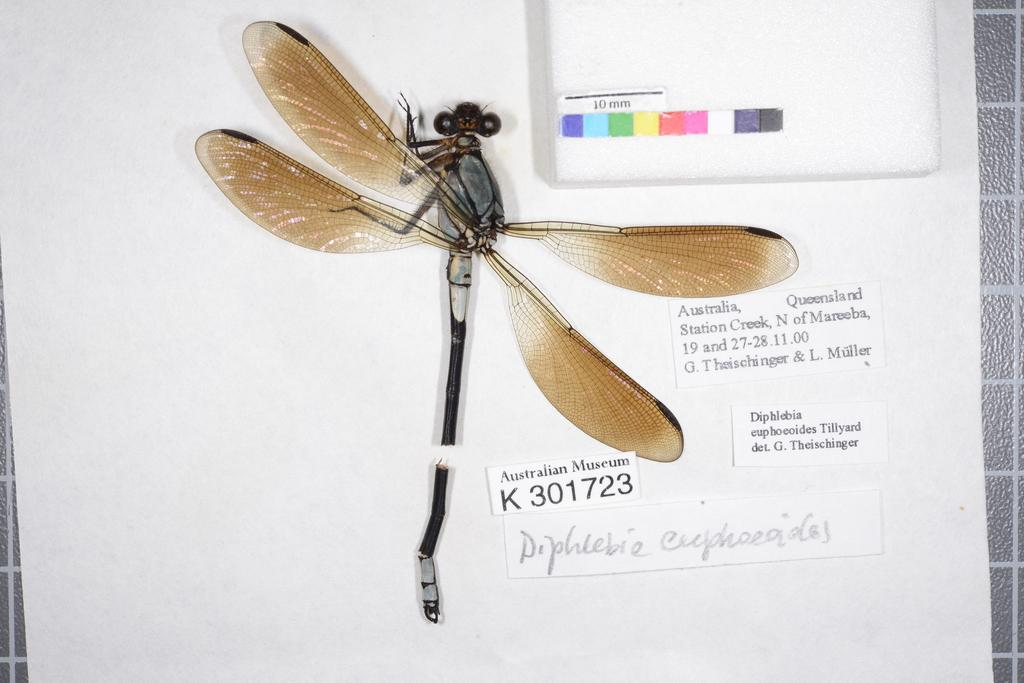What insect is present in the image? There is a dragonfly in the image. What is the background of the dragonfly? The dragonfly is on a white color paper. What else can be seen on the paper besides the dragonfly? There is text visible on the paper. What type of milk is being taxed in the image? There is no milk or tax-related information present in the image. 